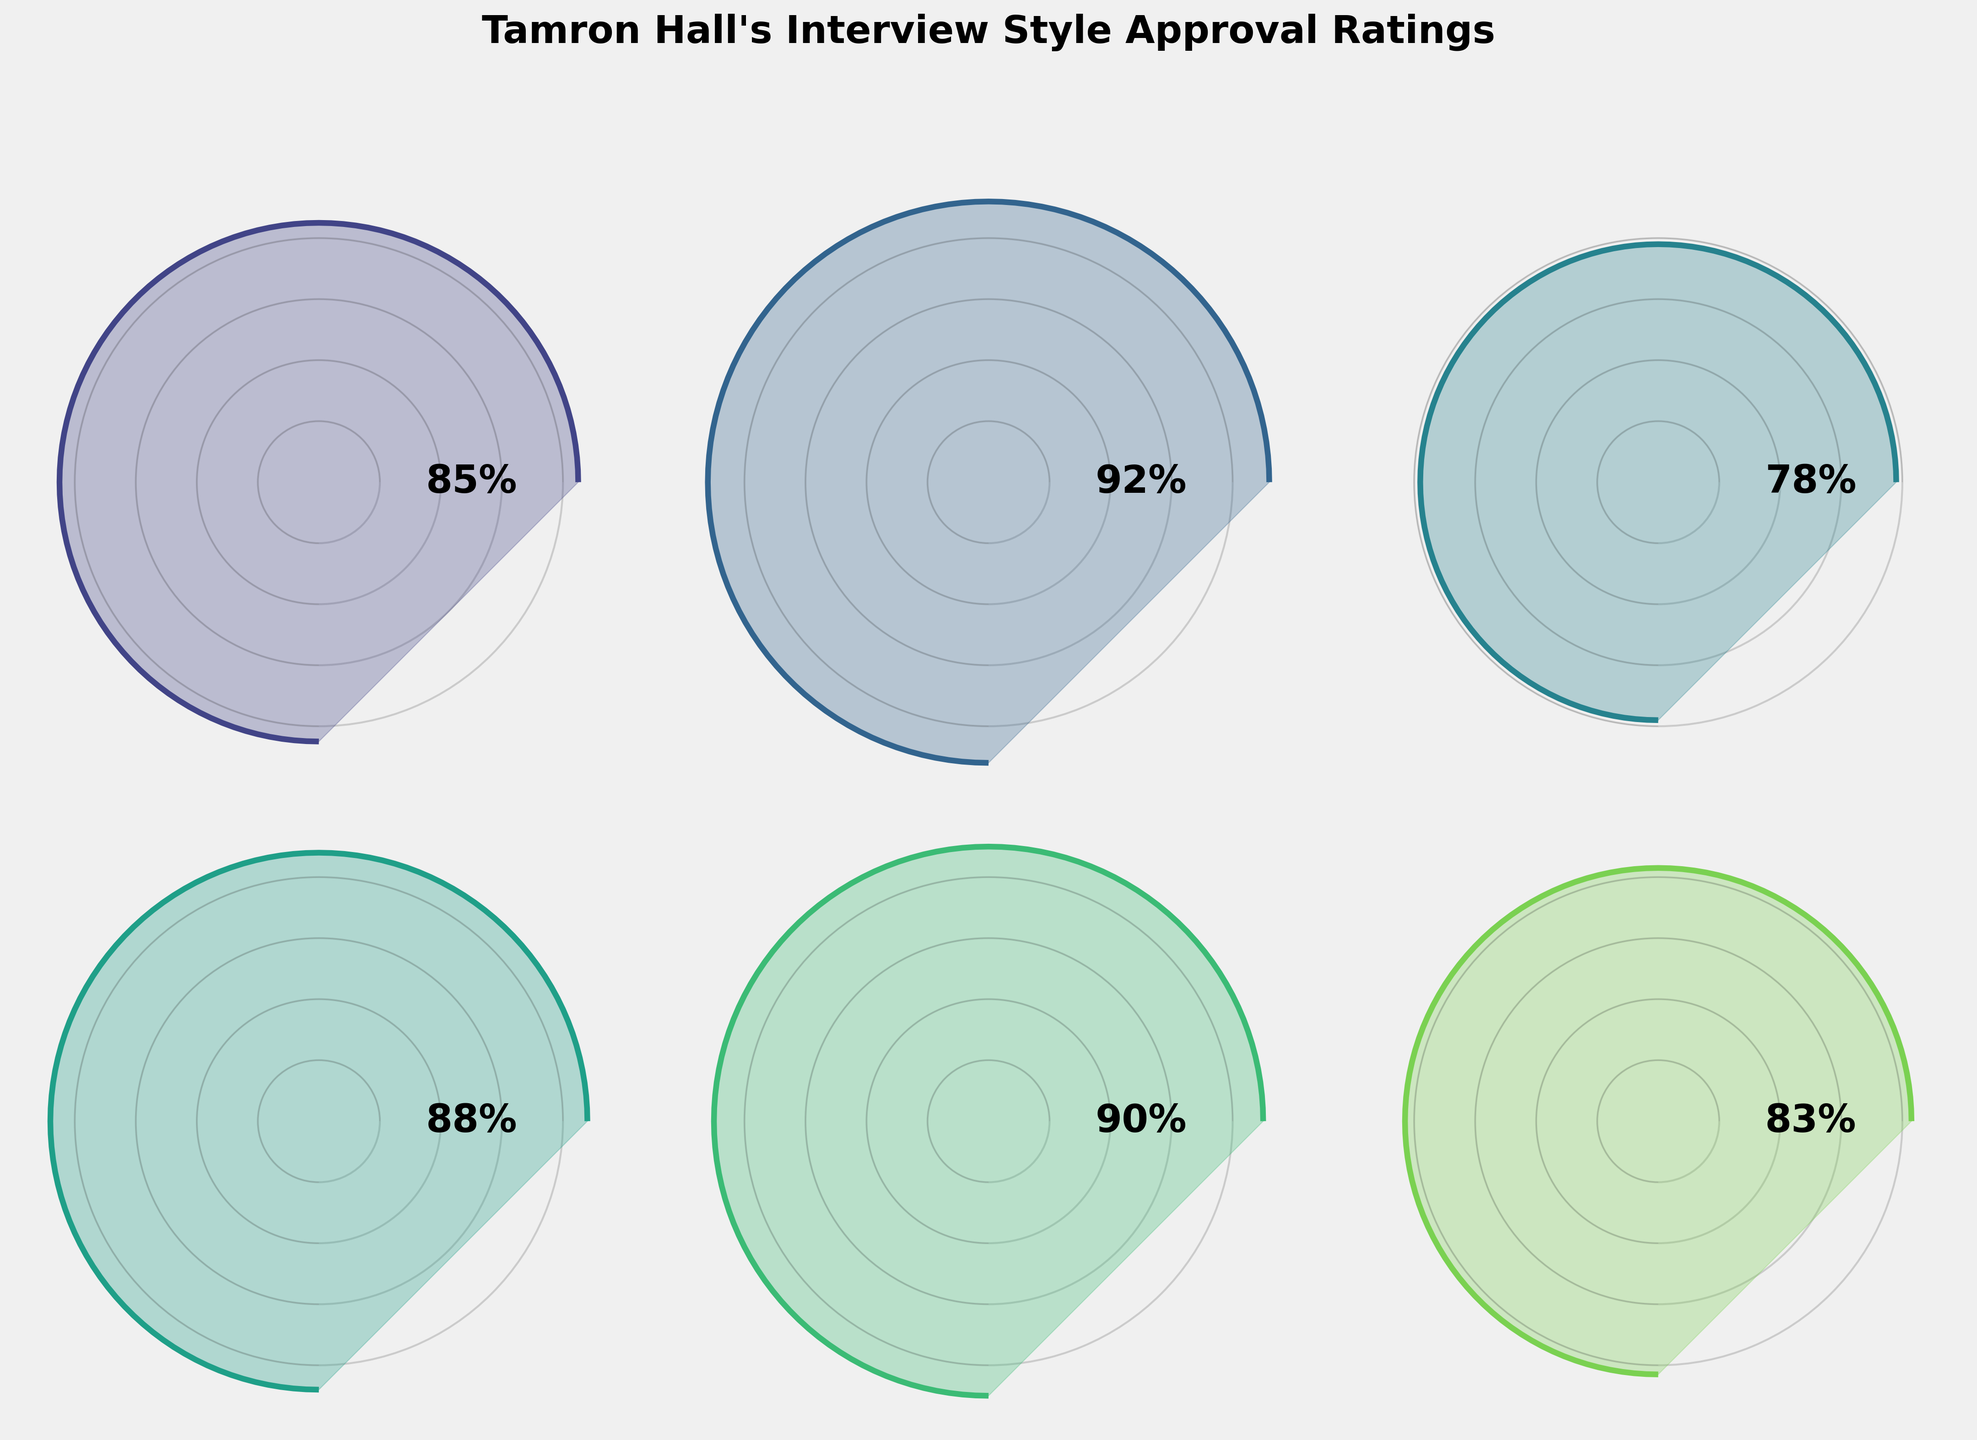What's the highest approval rating category? Look at all the categories and their corresponding approval ratings. The highest approval rating is for Warmth and Empathy at 92%.
Answer: Warmth and Empathy Which category has the lowest approval rating? Review the approval ratings for all categories. The lowest approval rating is for Incisive Questioning at 78%.
Answer: Incisive Questioning What is the average approval rating across all categories? Add the approval ratings of all categories: (85 + 92 + 78 + 88 + 90 + 83) = 516. Then, divide by the number of categories (6). The average is 516/6 ≈ 86%.
Answer: 86% How many categories have an approval rating above 85%? Identify all categories with approval ratings greater than 85: Warmth and Empathy (92), Topic Diversity (88), Guest Interaction (90). There are 3 categories.
Answer: 3 What's the approval rating for Audience Engagement? Find the approval rating corresponding to Audience Engagement, which is 83%.
Answer: 83% Which is higher, the approval rating for Guest Interaction or Incisive Questioning? Compare the approval ratings: Guest Interaction (90) and Incisive Questioning (78). Guest Interaction is higher.
Answer: Guest Interaction What is the difference in approval ratings between Overall Viewer Satisfaction and Topic Diversity? Subtract the approval rating of Topic Diversity from Overall Viewer Satisfaction: 85 - 88 = -3. The difference is -3%.
Answer: -3% How much higher is the Warmth and Empathy rating compared to the Audience Engagement rating? Subtract the approval rating of Audience Engagement from Warmth and Empathy: 92 - 83 = 9. The Warmth and Empathy rating is 9% higher.
Answer: 9% Which category's approval rating is closest to 90%? Compare how close each category's rating is to 90%. Guest Interaction is exactly 90%.
Answer: Guest Interaction What range do the approval ratings fall within? Identify the minimum and maximum approval ratings. The minimum is Incisive Questioning at 78%, and the maximum is Warmth and Empathy at 92%. The range is 78% to 92%.
Answer: 78%-92% 